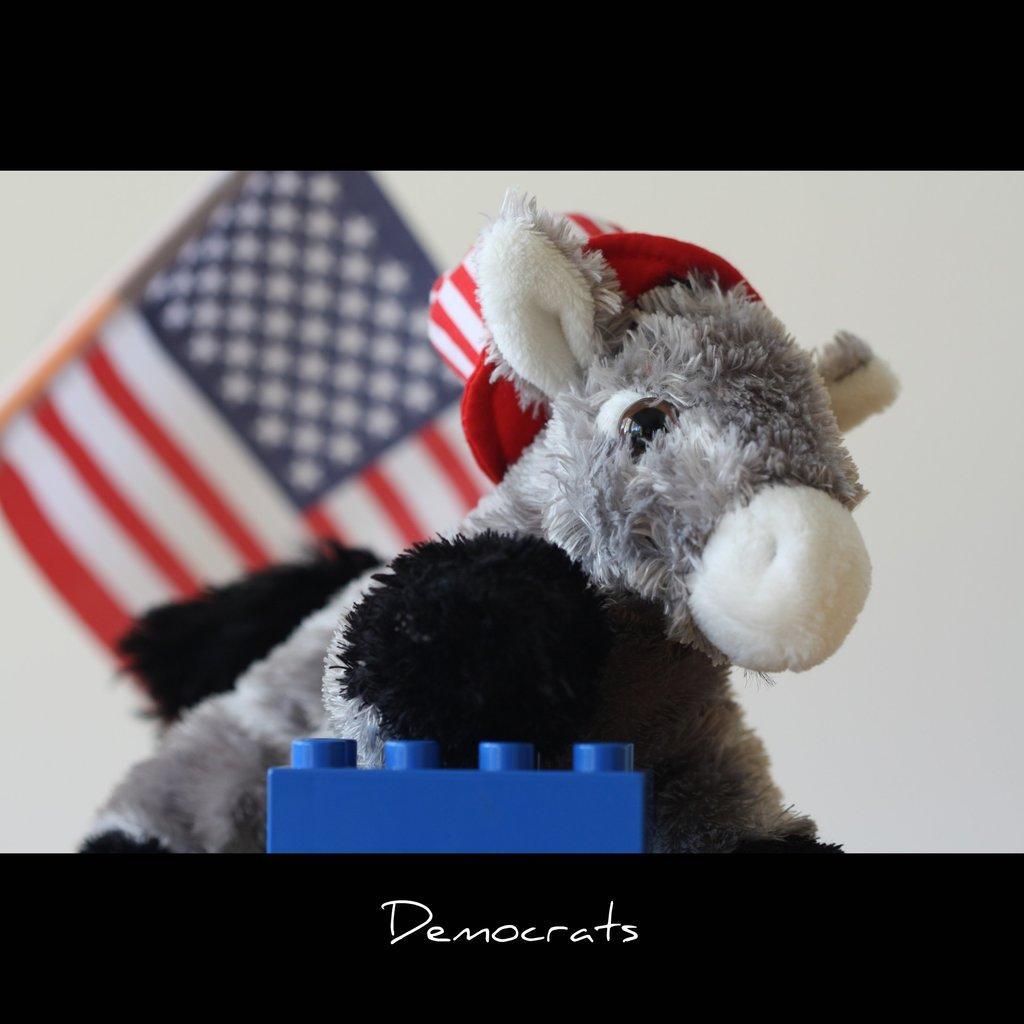Can you describe this image briefly? This is an edited image, in this image there is a toy, in the background there is a flag and a wall, at the bottom there is some text. 